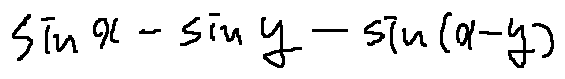Convert formula to latex. <formula><loc_0><loc_0><loc_500><loc_500>\sin x - \sin y - \sin ( x - y )</formula> 